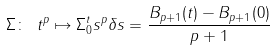Convert formula to latex. <formula><loc_0><loc_0><loc_500><loc_500>\Sigma \colon \ t ^ { p } \mapsto \Sigma _ { 0 } ^ { t } s ^ { p } \delta s = \frac { B _ { p + 1 } ( t ) - B _ { p + 1 } ( 0 ) } { p + 1 }</formula> 